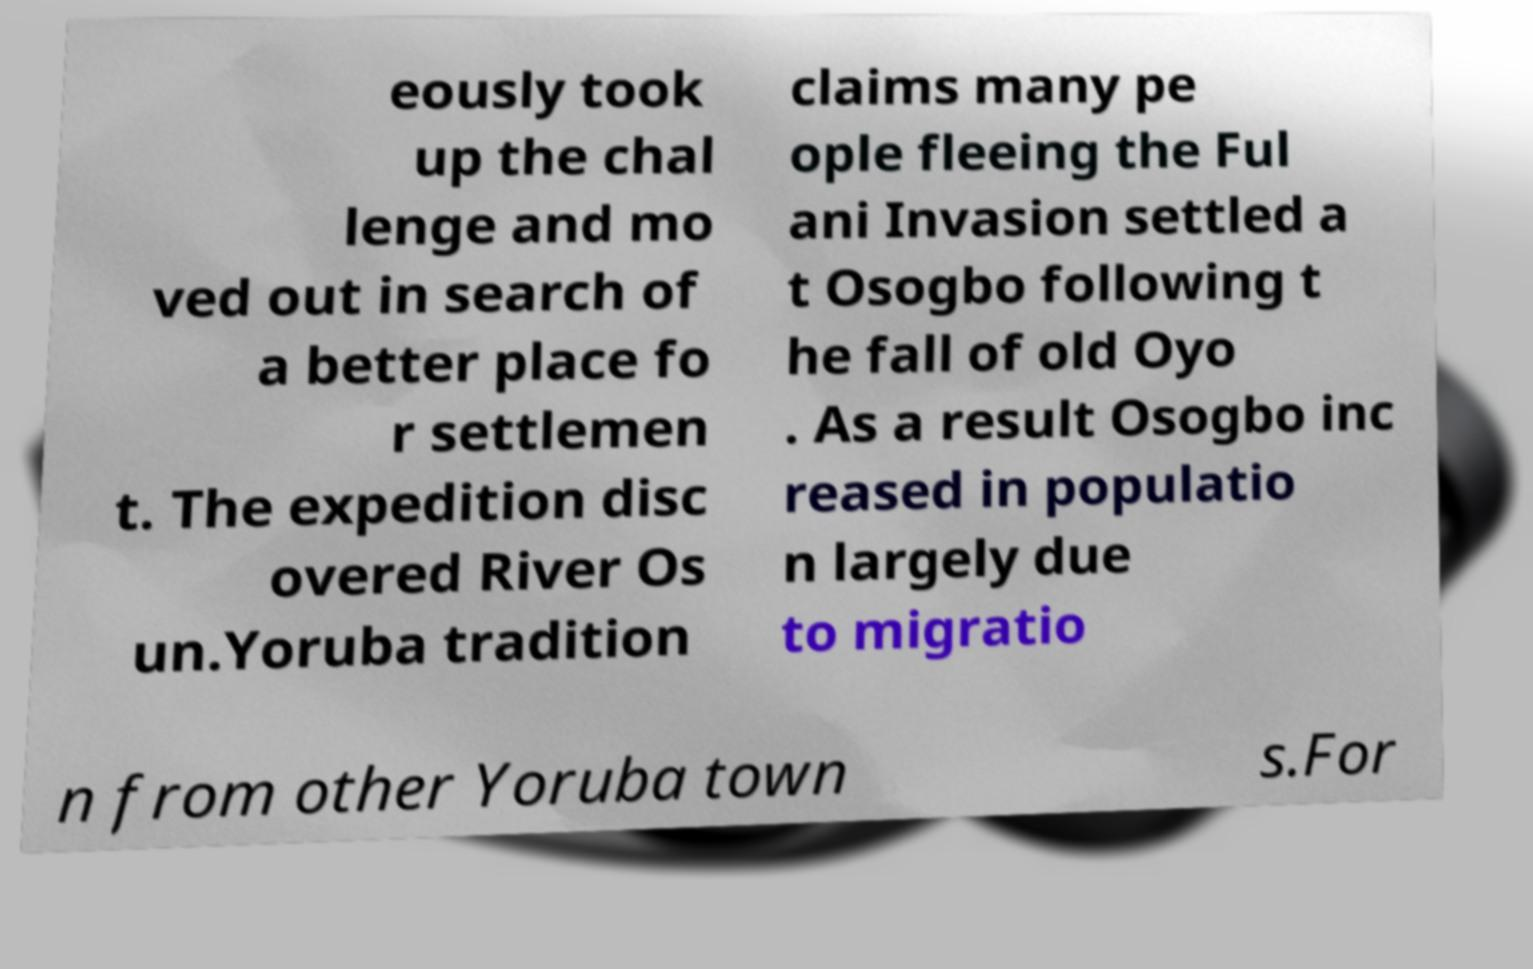Please read and relay the text visible in this image. What does it say? eously took up the chal lenge and mo ved out in search of a better place fo r settlemen t. The expedition disc overed River Os un.Yoruba tradition claims many pe ople fleeing the Ful ani Invasion settled a t Osogbo following t he fall of old Oyo . As a result Osogbo inc reased in populatio n largely due to migratio n from other Yoruba town s.For 